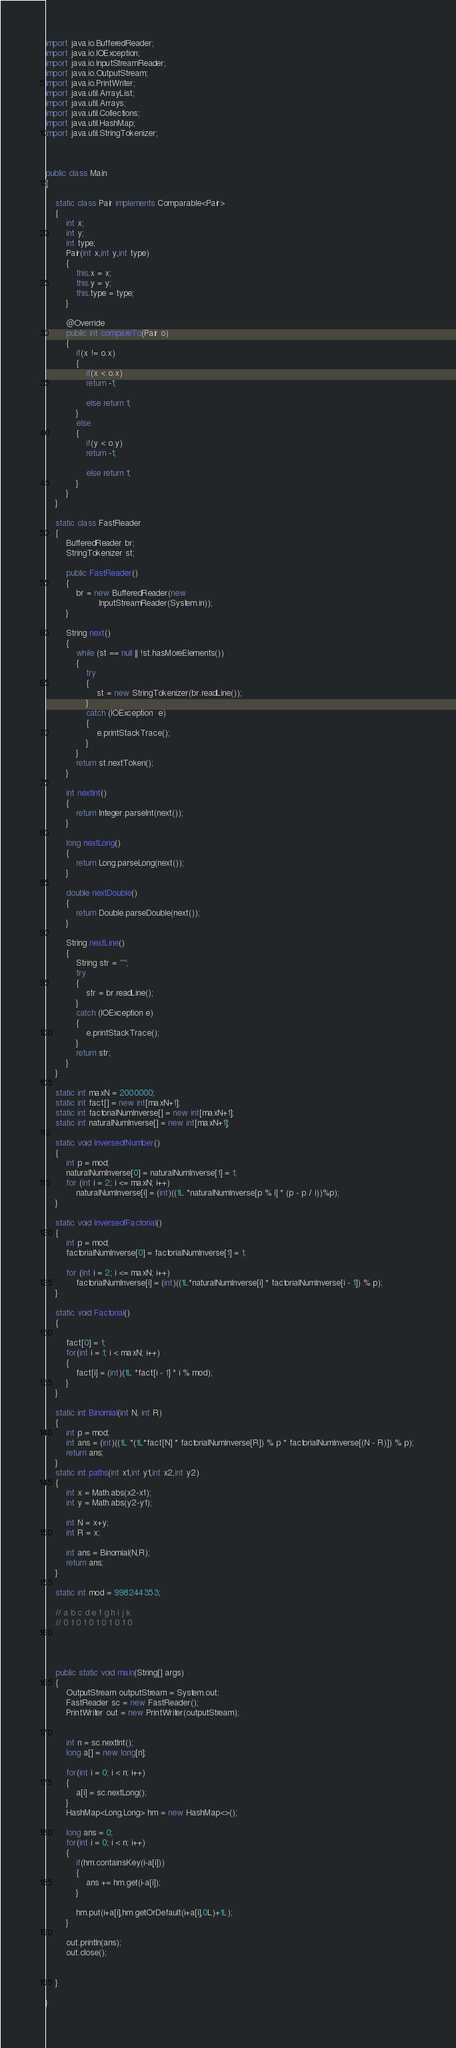<code> <loc_0><loc_0><loc_500><loc_500><_Java_>import java.io.BufferedReader;
import java.io.IOException;
import java.io.InputStreamReader;
import java.io.OutputStream;
import java.io.PrintWriter;
import java.util.ArrayList;
import java.util.Arrays;
import java.util.Collections;
import java.util.HashMap;
import java.util.StringTokenizer;



public class Main
{	
	
	static class Pair implements Comparable<Pair>
	{
		int x;
		int y;
		int type;
		Pair(int x,int y,int type)
		{
			this.x = x;
			this.y = y;
			this.type = type;
		}
		
		@Override
		public int compareTo(Pair o)
		{
			if(x != o.x)
			{	
				if(x < o.x)
				return -1;
				
				else return 1;
			}
			else
			{	
				if(y < o.y)
				return -1;
				
				else return 1;
			}
		}
	}
	 
	static class FastReader 
	{ 
	    BufferedReader br; 
	    StringTokenizer st; 

	    public FastReader() 
	    { 
	        br = new BufferedReader(new
	                 InputStreamReader(System.in)); 
	    } 

	    String next() 
	    { 
	        while (st == null || !st.hasMoreElements()) 
	        { 
	            try
	            { 
	                st = new StringTokenizer(br.readLine()); 
	            } 
	            catch (IOException  e) 
	            { 
	                e.printStackTrace(); 
	            } 
	        } 
	        return st.nextToken(); 
	    } 

	    int nextInt() 
	    { 
	        return Integer.parseInt(next()); 
	    } 

	    long nextLong() 
	    { 
	        return Long.parseLong(next()); 
	    } 

	    double nextDouble() 
	    { 
	        return Double.parseDouble(next()); 
	    } 

	    String nextLine() 
	    { 
	        String str = ""; 
	        try
	        { 
	            str = br.readLine(); 
	        } 
	        catch (IOException e) 
	        { 
	            e.printStackTrace(); 
	        } 
	        return str; 
	    } 
	}

	static int maxN = 2000000;
	static int fact[] = new int[maxN+1];
	static int factorialNumInverse[] = new int[maxN+1];
	static int naturalNumInverse[] = new int[maxN+1];
	
	static void InverseofNumber() 
	{ 	
		int p = mod;
	    naturalNumInverse[0] = naturalNumInverse[1] = 1; 
	    for (int i = 2; i <= maxN; i++) 
	        naturalNumInverse[i] = (int)((1L *naturalNumInverse[p % i] * (p - p / i))%p); 
	}
	
	static void InverseofFactorial() 
	{ 	
		int p = mod;
	    factorialNumInverse[0] = factorialNumInverse[1] = 1; 
	  
	    for (int i = 2; i <= maxN; i++) 
	        factorialNumInverse[i] = (int)((1L*naturalNumInverse[i] * factorialNumInverse[i - 1]) % p); 
	} 
	
	static void Factorial()
	{
		
		fact[0] = 1;
		for(int i = 1; i < maxN; i++) 
		{
			fact[i] = (int)(1L *fact[i - 1] * i % mod);
		}
	}
	
	static int Binomial(int N, int R) 
	{ 
	    int p = mod;
	    int ans = (int)((1L *(1L*fact[N] * factorialNumInverse[R]) % p * factorialNumInverse[(N - R)]) % p); 
	    return ans; 
	} 
	static int paths(int x1,int y1,int x2,int y2)
	{	
		int x = Math.abs(x2-x1);
		int y = Math.abs(y2-y1);
		
		int N = x+y;
		int R = x;
		
		int ans = Binomial(N,R);
		return ans;
	}
	
	static int mod = 998244353;
	
	// a b c d e f g h i j k
	// 0 1 0 1 0 1 0 1 0 1 0
	
	
	
	
	public static void main(String[] args) 
	{
		OutputStream outputStream = System.out;
		FastReader sc = new FastReader();
        PrintWriter out = new PrintWriter(outputStream);
        
        
        int n = sc.nextInt();
        long a[] = new long[n];
        
        for(int i = 0; i < n; i++)
        {
        	a[i] = sc.nextLong();
        }
        HashMap<Long,Long> hm = new HashMap<>();
        
        long ans = 0;
        for(int i = 0; i < n; i++)
        {
        	if(hm.containsKey(i-a[i]))
        	{
        		ans += hm.get(i-a[i]);
        	}
        	
        	hm.put(i+a[i],hm.getOrDefault(i+a[i],0L)+1L);
        }
        
        out.println(ans);
        out.close();
        

	}
 
}</code> 